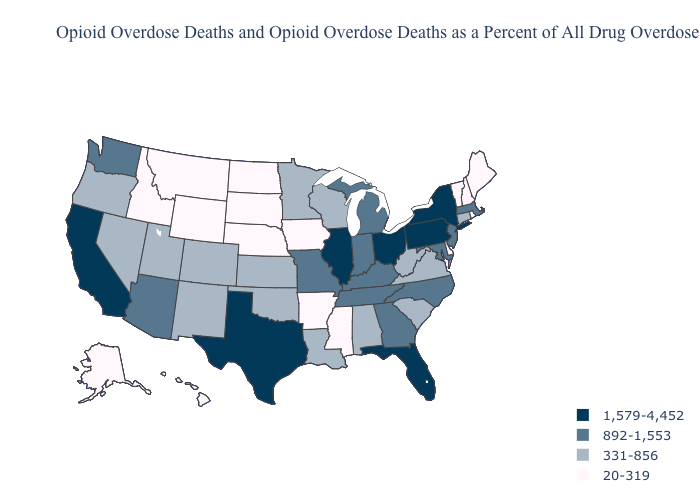What is the value of Alabama?
Give a very brief answer. 331-856. Does the first symbol in the legend represent the smallest category?
Give a very brief answer. No. Name the states that have a value in the range 892-1,553?
Be succinct. Arizona, Georgia, Indiana, Kentucky, Maryland, Massachusetts, Michigan, Missouri, New Jersey, North Carolina, Tennessee, Washington. What is the value of West Virginia?
Keep it brief. 331-856. Does Massachusetts have a higher value than Alabama?
Write a very short answer. Yes. What is the value of Illinois?
Give a very brief answer. 1,579-4,452. Name the states that have a value in the range 331-856?
Be succinct. Alabama, Colorado, Connecticut, Kansas, Louisiana, Minnesota, Nevada, New Mexico, Oklahoma, Oregon, South Carolina, Utah, Virginia, West Virginia, Wisconsin. What is the value of New Hampshire?
Write a very short answer. 20-319. Among the states that border Colorado , which have the highest value?
Answer briefly. Arizona. Which states have the lowest value in the West?
Give a very brief answer. Alaska, Hawaii, Idaho, Montana, Wyoming. Name the states that have a value in the range 331-856?
Write a very short answer. Alabama, Colorado, Connecticut, Kansas, Louisiana, Minnesota, Nevada, New Mexico, Oklahoma, Oregon, South Carolina, Utah, Virginia, West Virginia, Wisconsin. Among the states that border Pennsylvania , which have the lowest value?
Keep it brief. Delaware. Name the states that have a value in the range 892-1,553?
Give a very brief answer. Arizona, Georgia, Indiana, Kentucky, Maryland, Massachusetts, Michigan, Missouri, New Jersey, North Carolina, Tennessee, Washington. What is the value of Nebraska?
Concise answer only. 20-319. Among the states that border Washington , does Idaho have the lowest value?
Write a very short answer. Yes. 